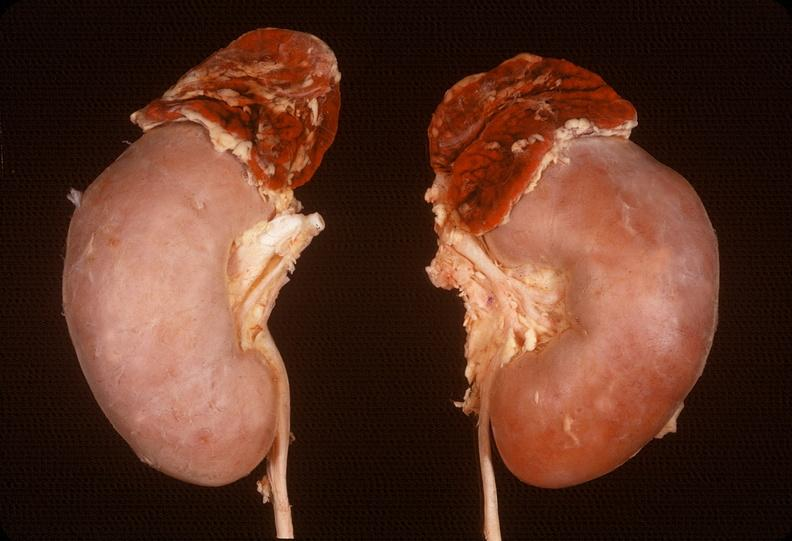does slide show adrenal, hemorrhage?
Answer the question using a single word or phrase. No 